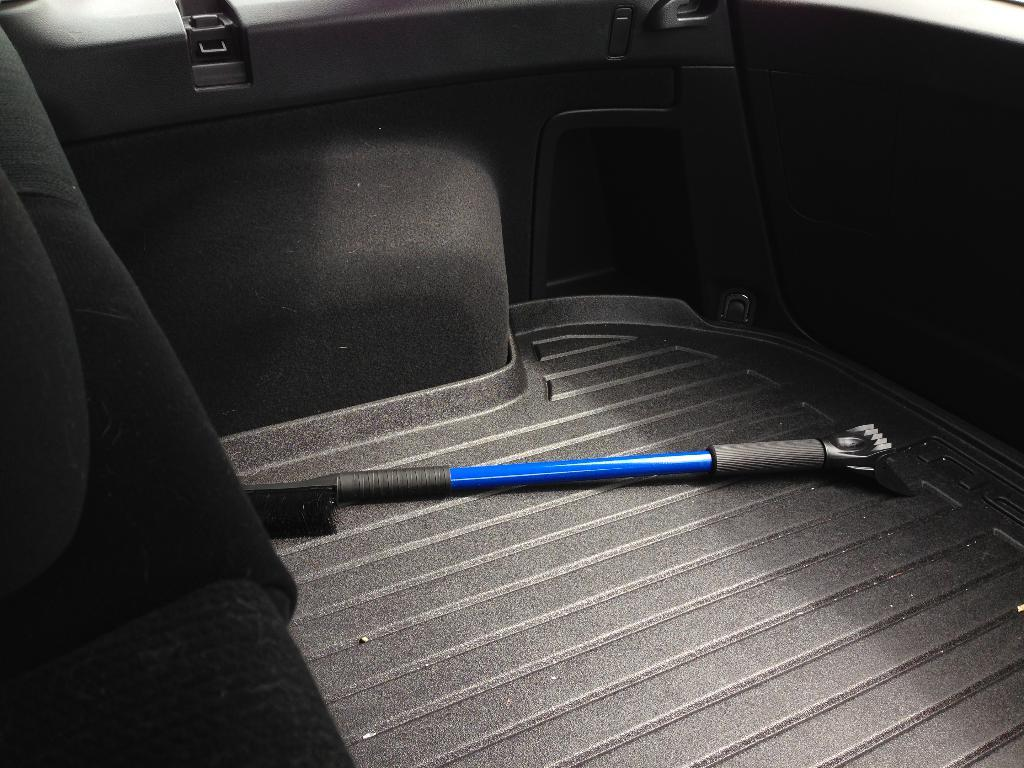What object is placed on the surface of the vehicle in the image? There is a tool placed on the surface of a vehicle in the image. What can be seen on the left side of the image? There are seats on the left side of the image. What flavor of ice cream is being served on the roof in the image? There is no ice cream or roof present in the image; it features a tool placed on a vehicle and seats on the left side. 